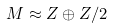Convert formula to latex. <formula><loc_0><loc_0><loc_500><loc_500>M \approx Z \oplus Z / 2</formula> 